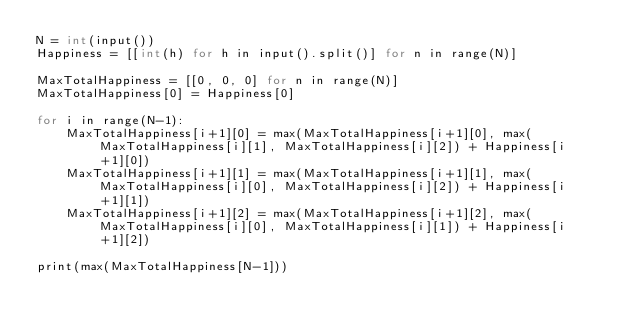Convert code to text. <code><loc_0><loc_0><loc_500><loc_500><_C++_>N = int(input())
Happiness = [[int(h) for h in input().split()] for n in range(N)]

MaxTotalHappiness = [[0, 0, 0] for n in range(N)]
MaxTotalHappiness[0] = Happiness[0]

for i in range(N-1):
    MaxTotalHappiness[i+1][0] = max(MaxTotalHappiness[i+1][0], max(MaxTotalHappiness[i][1], MaxTotalHappiness[i][2]) + Happiness[i+1][0])
    MaxTotalHappiness[i+1][1] = max(MaxTotalHappiness[i+1][1], max(MaxTotalHappiness[i][0], MaxTotalHappiness[i][2]) + Happiness[i+1][1])
    MaxTotalHappiness[i+1][2] = max(MaxTotalHappiness[i+1][2], max(MaxTotalHappiness[i][0], MaxTotalHappiness[i][1]) + Happiness[i+1][2])

print(max(MaxTotalHappiness[N-1]))</code> 